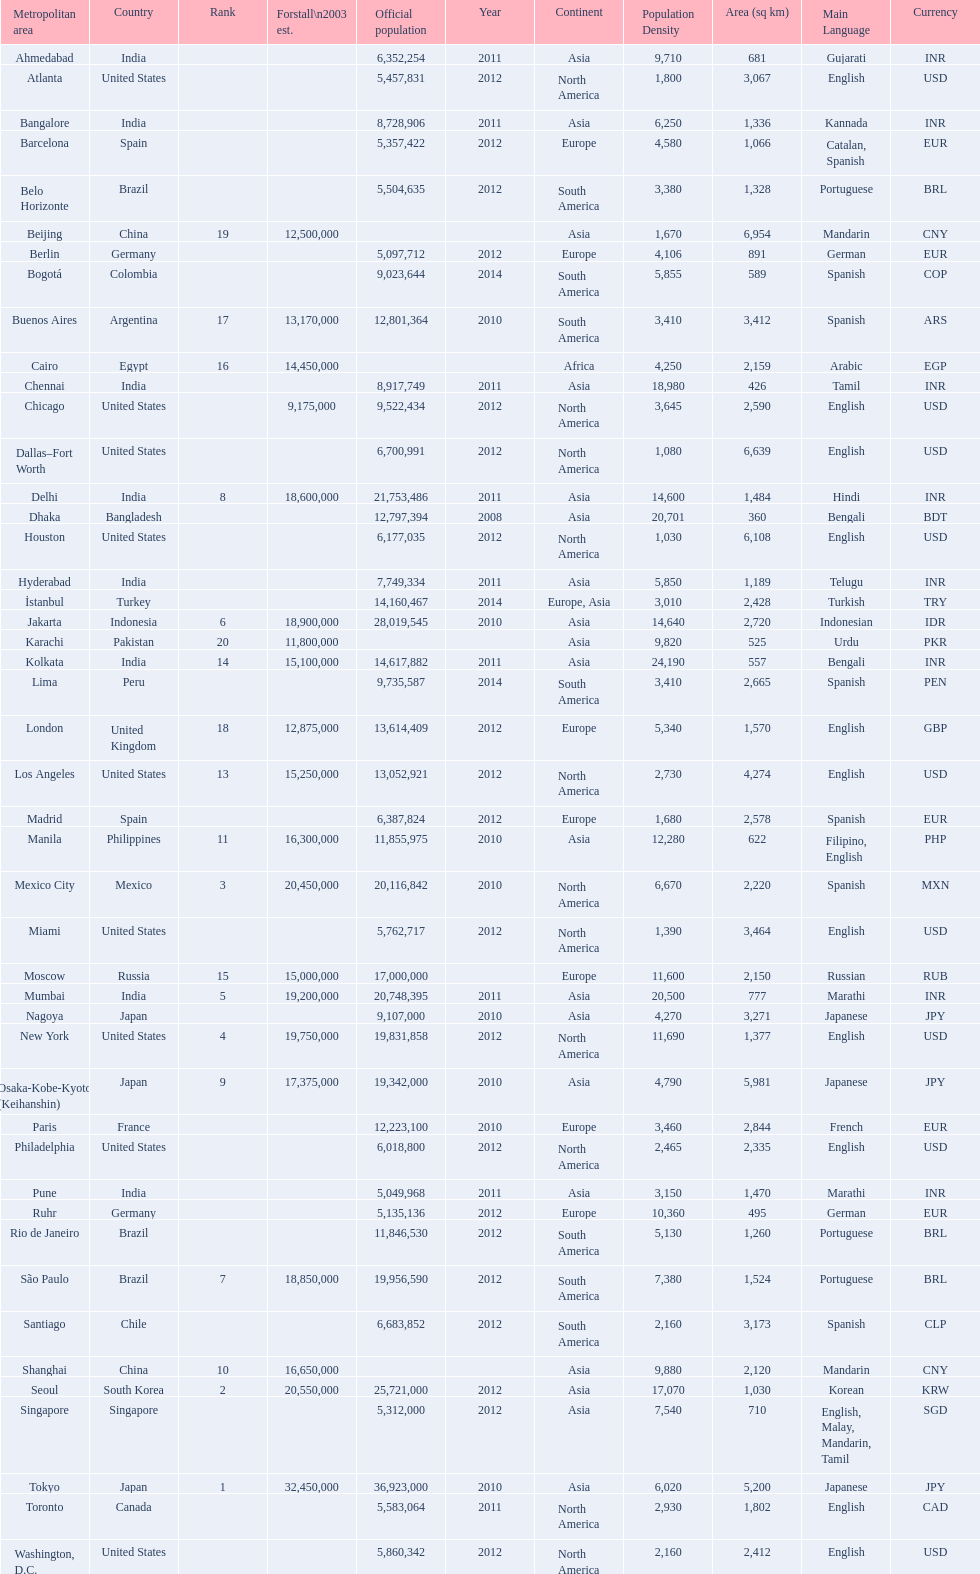Name a city from the same country as bangalore. Ahmedabad. 